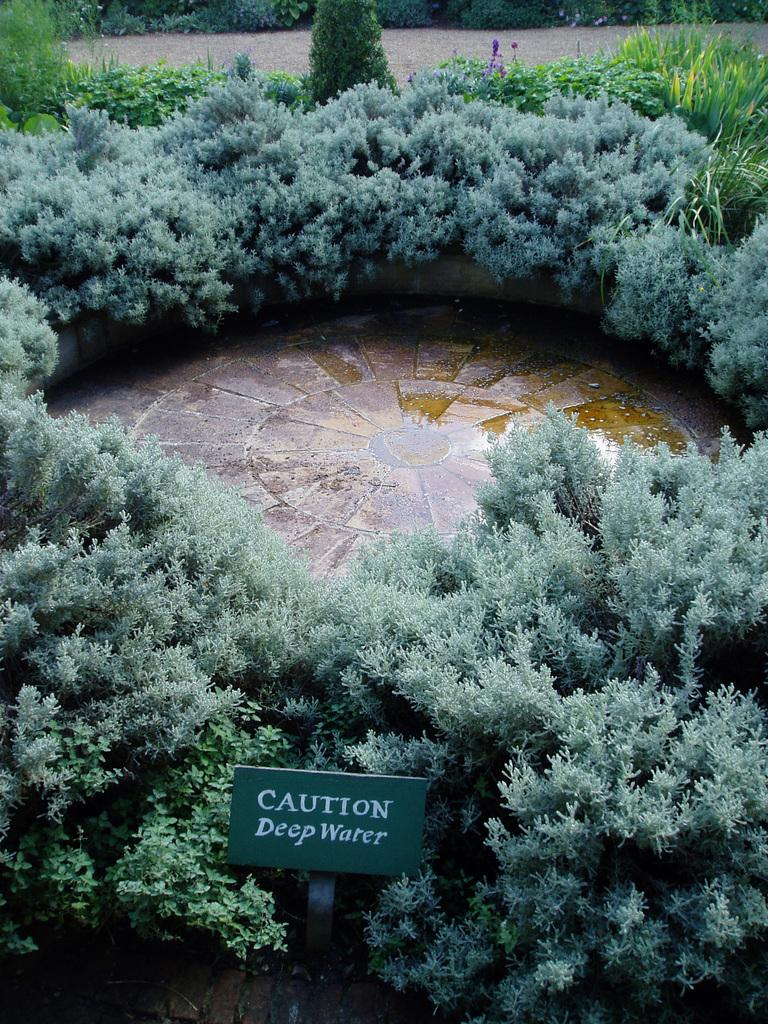What can be seen under the feet of the people or objects in the image? The ground is visible in the image. What type of vegetation is present in the image? There are trees and plants in the image. What is the purpose of the board with text in the image? The purpose of the board with text is not clear from the image alone, but it might be used for communication or displaying information. What type of straw is being used to create the aftermath of the event in the image? A: There is no straw or event present in the image, so it is not possible to determine what type of straw might be used or what the aftermath of an event would look like. 